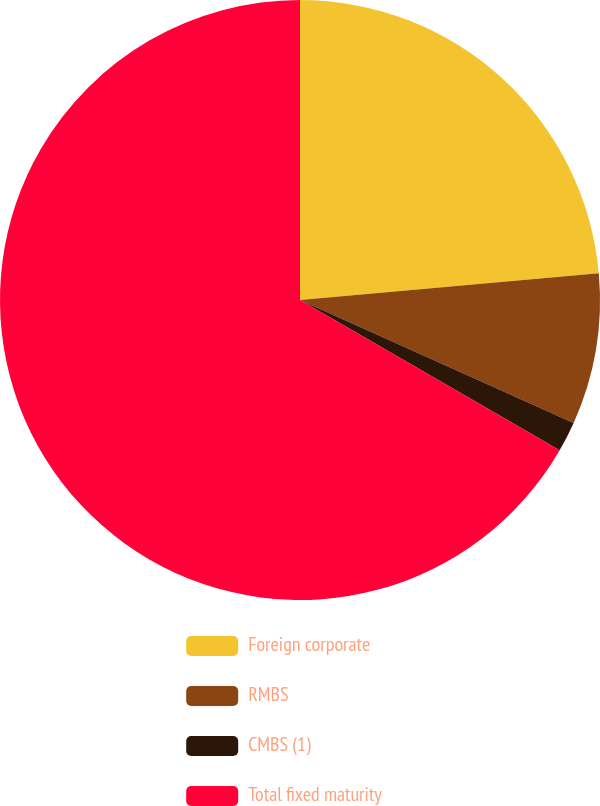Convert chart to OTSL. <chart><loc_0><loc_0><loc_500><loc_500><pie_chart><fcel>Foreign corporate<fcel>RMBS<fcel>CMBS (1)<fcel>Total fixed maturity<nl><fcel>23.58%<fcel>8.14%<fcel>1.63%<fcel>66.65%<nl></chart> 